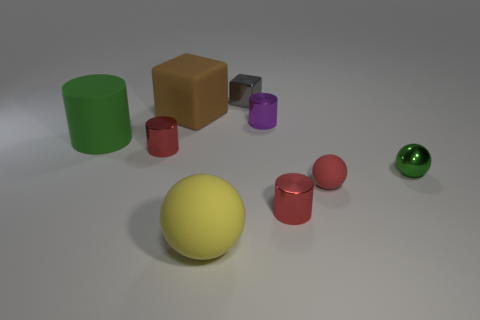Subtract 1 cylinders. How many cylinders are left? 3 Subtract all spheres. How many objects are left? 6 Add 4 large yellow rubber spheres. How many large yellow rubber spheres exist? 5 Subtract 1 green cylinders. How many objects are left? 8 Subtract all yellow objects. Subtract all objects. How many objects are left? 7 Add 8 large yellow matte spheres. How many large yellow matte spheres are left? 9 